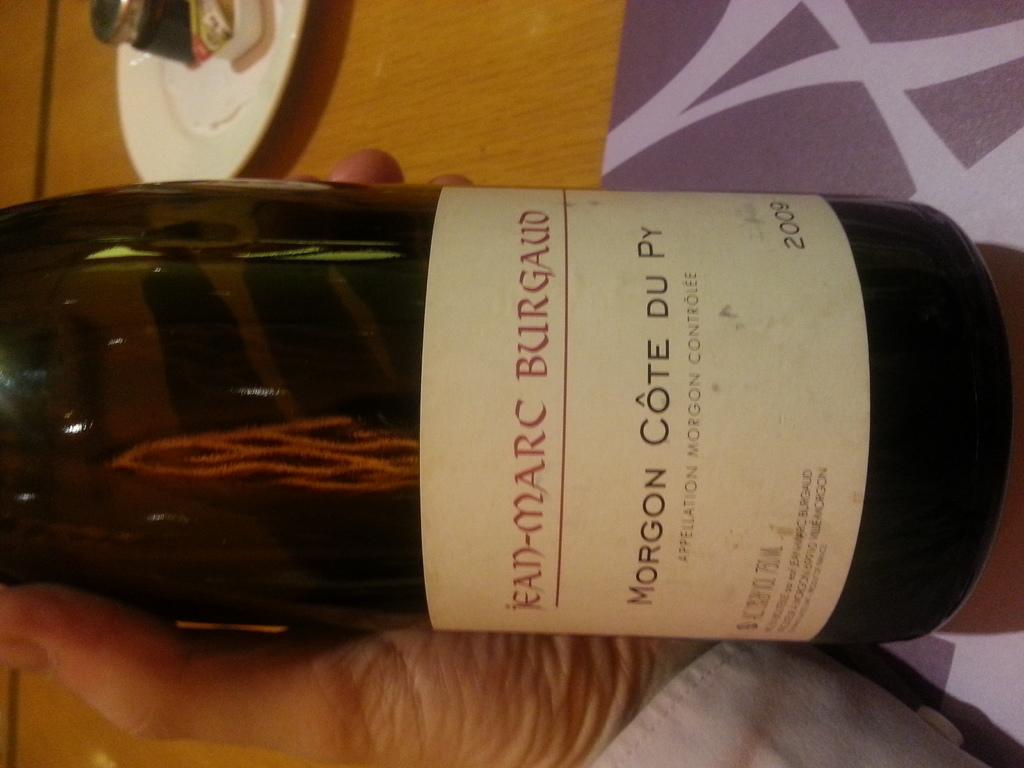What year was this wine made?
Your response must be concise. 2009. What brand of wine is this?
Your response must be concise. Jean-marc burgaud. 